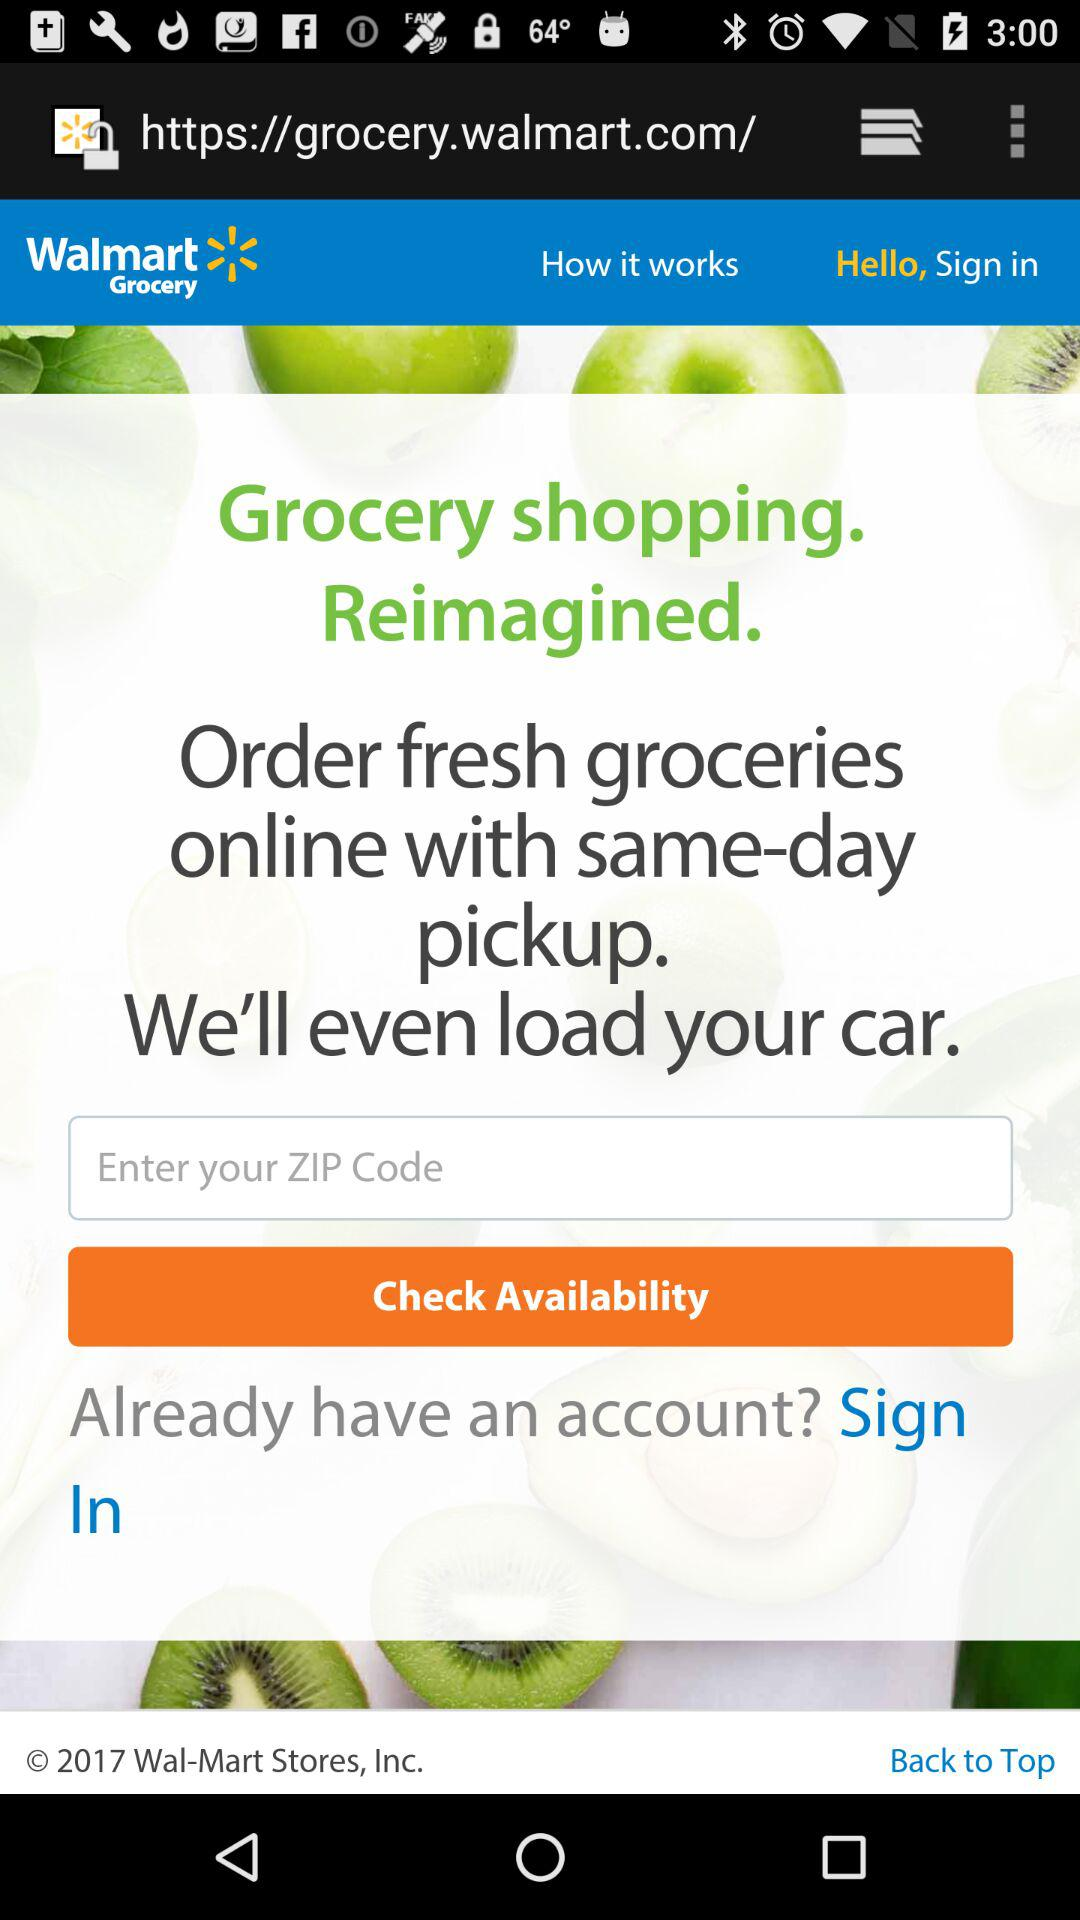What is the entered zip code?
When the provided information is insufficient, respond with <no answer>. <no answer> 